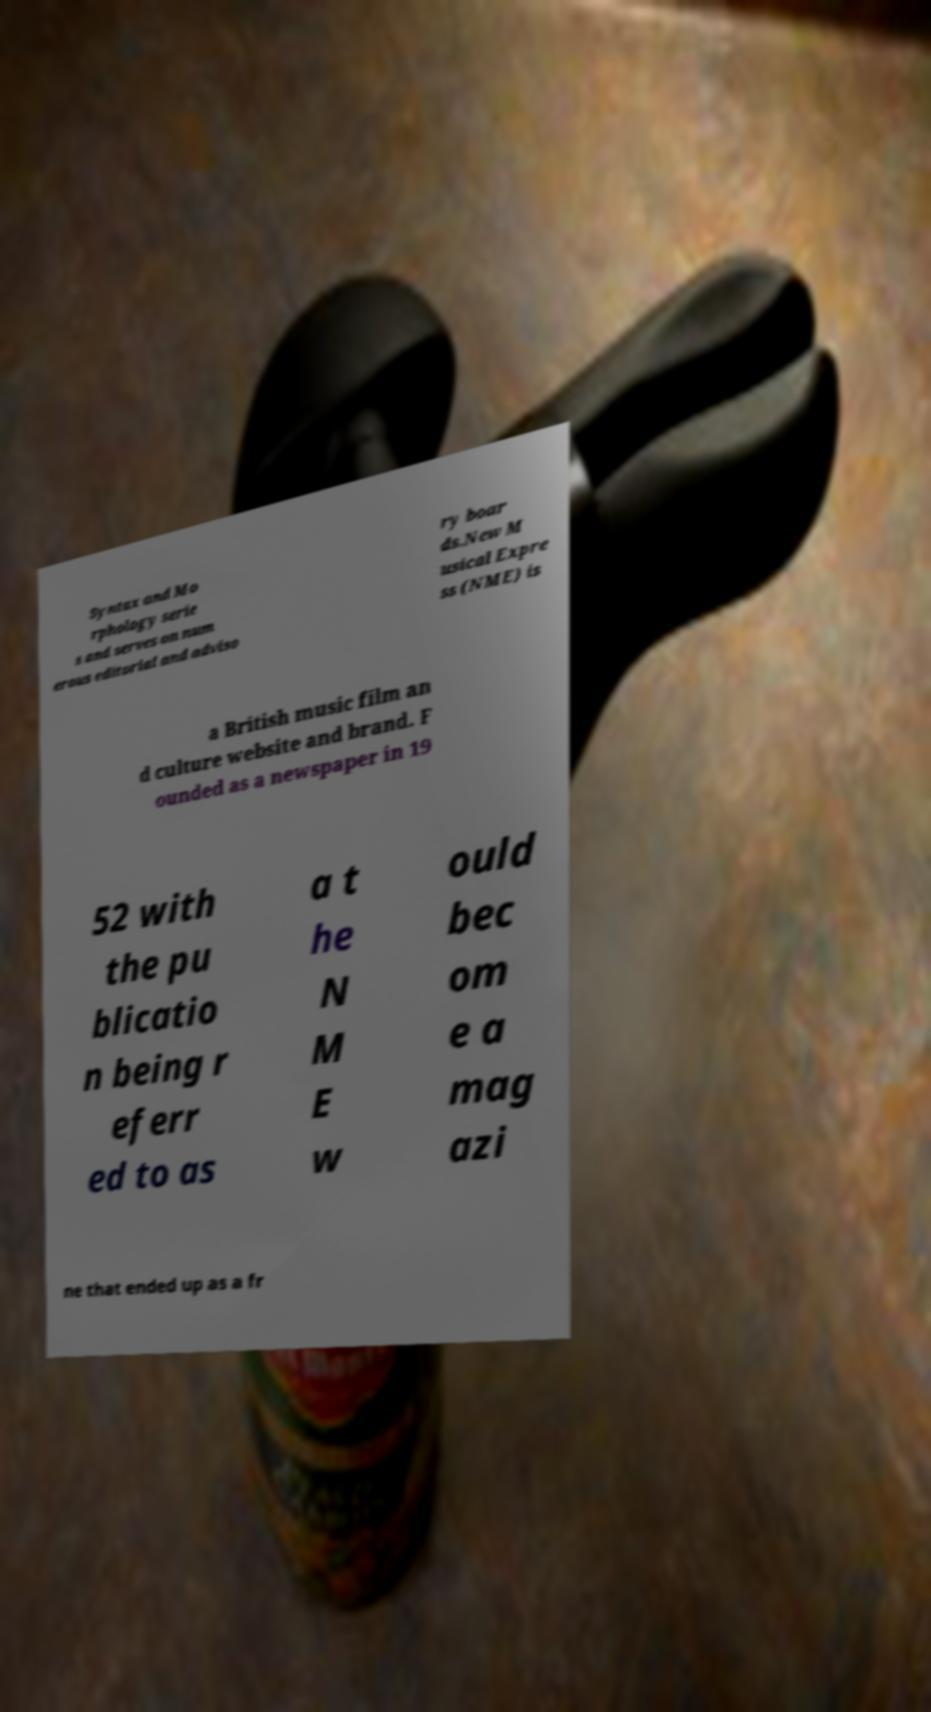Could you extract and type out the text from this image? Syntax and Mo rphology serie s and serves on num erous editorial and adviso ry boar ds.New M usical Expre ss (NME) is a British music film an d culture website and brand. F ounded as a newspaper in 19 52 with the pu blicatio n being r eferr ed to as a t he N M E w ould bec om e a mag azi ne that ended up as a fr 